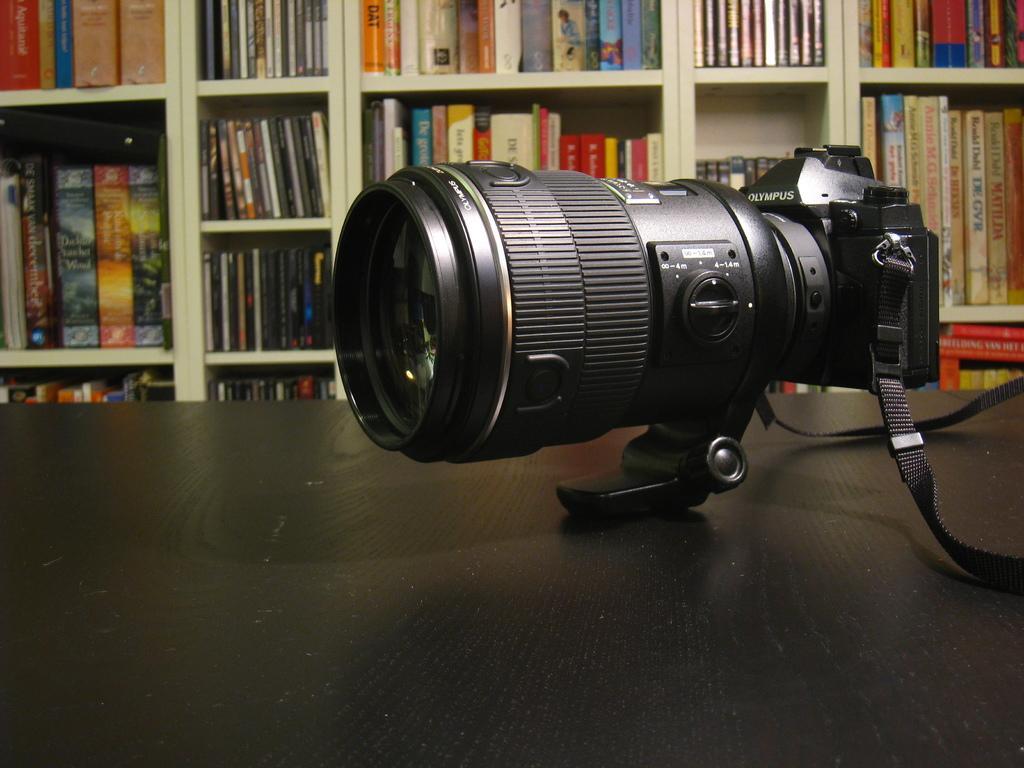Can you describe this image briefly? In this picture, we can see a camera on the black color object, in the background, we can see some shelves and books in it. 